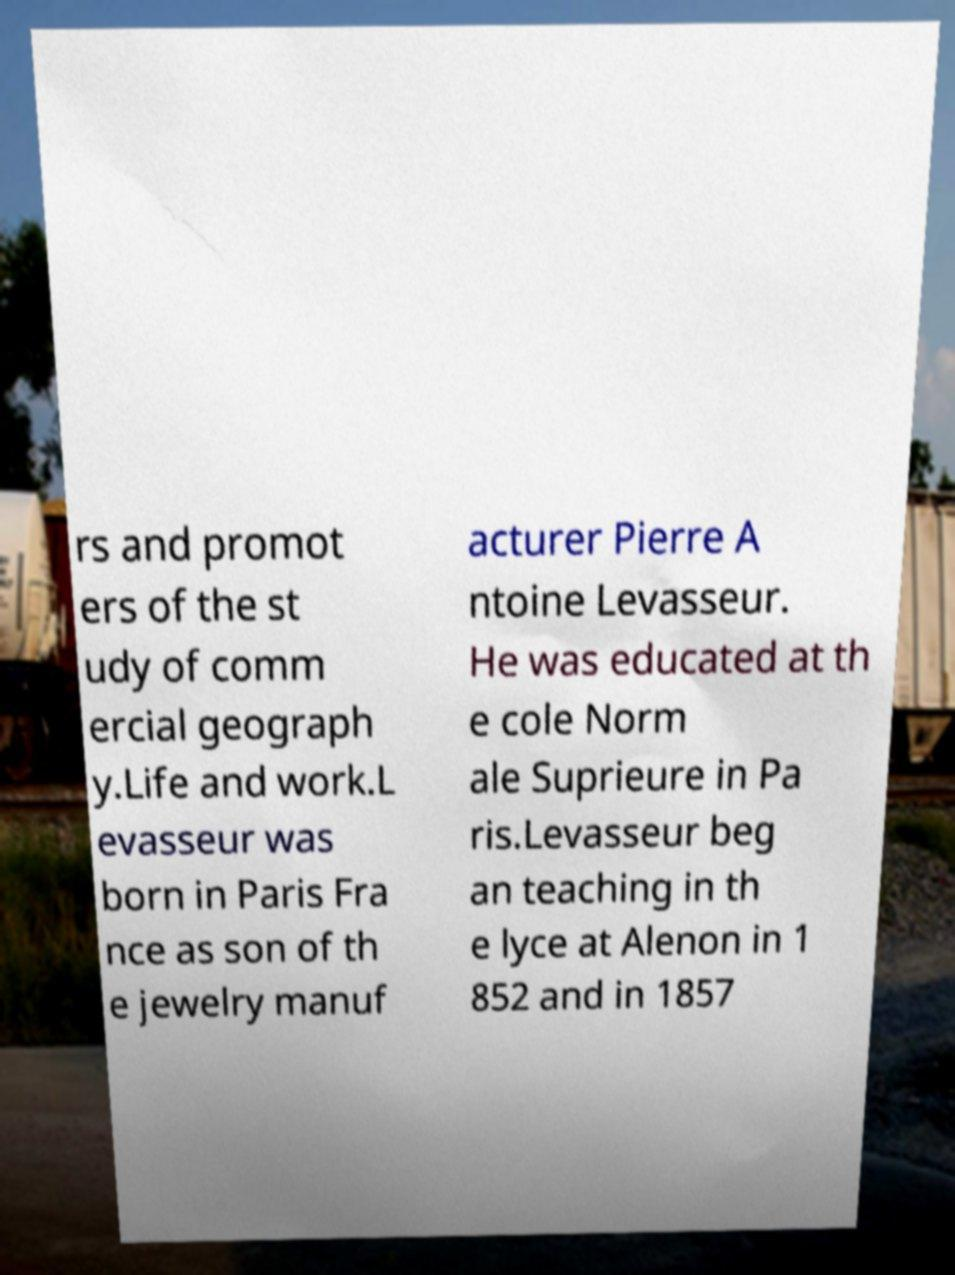Can you read and provide the text displayed in the image?This photo seems to have some interesting text. Can you extract and type it out for me? rs and promot ers of the st udy of comm ercial geograph y.Life and work.L evasseur was born in Paris Fra nce as son of th e jewelry manuf acturer Pierre A ntoine Levasseur. He was educated at th e cole Norm ale Suprieure in Pa ris.Levasseur beg an teaching in th e lyce at Alenon in 1 852 and in 1857 